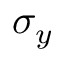Convert formula to latex. <formula><loc_0><loc_0><loc_500><loc_500>\sigma _ { y }</formula> 